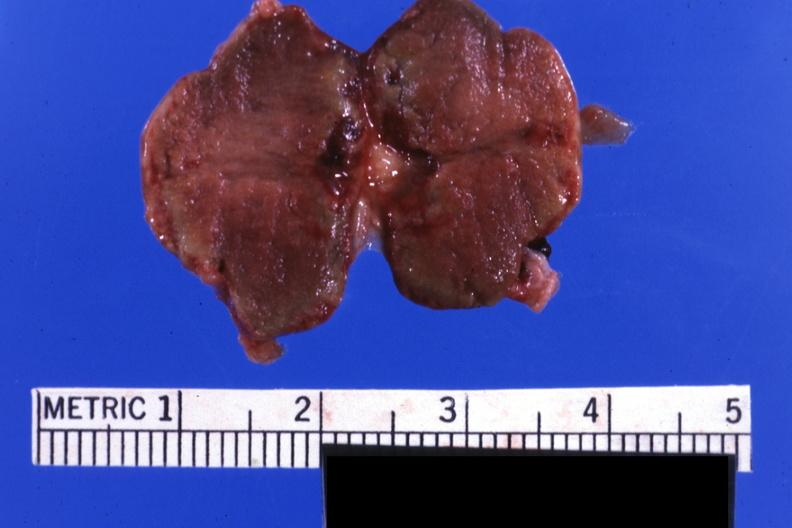s conjoined twins present?
Answer the question using a single word or phrase. No 